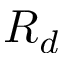Convert formula to latex. <formula><loc_0><loc_0><loc_500><loc_500>R _ { d }</formula> 